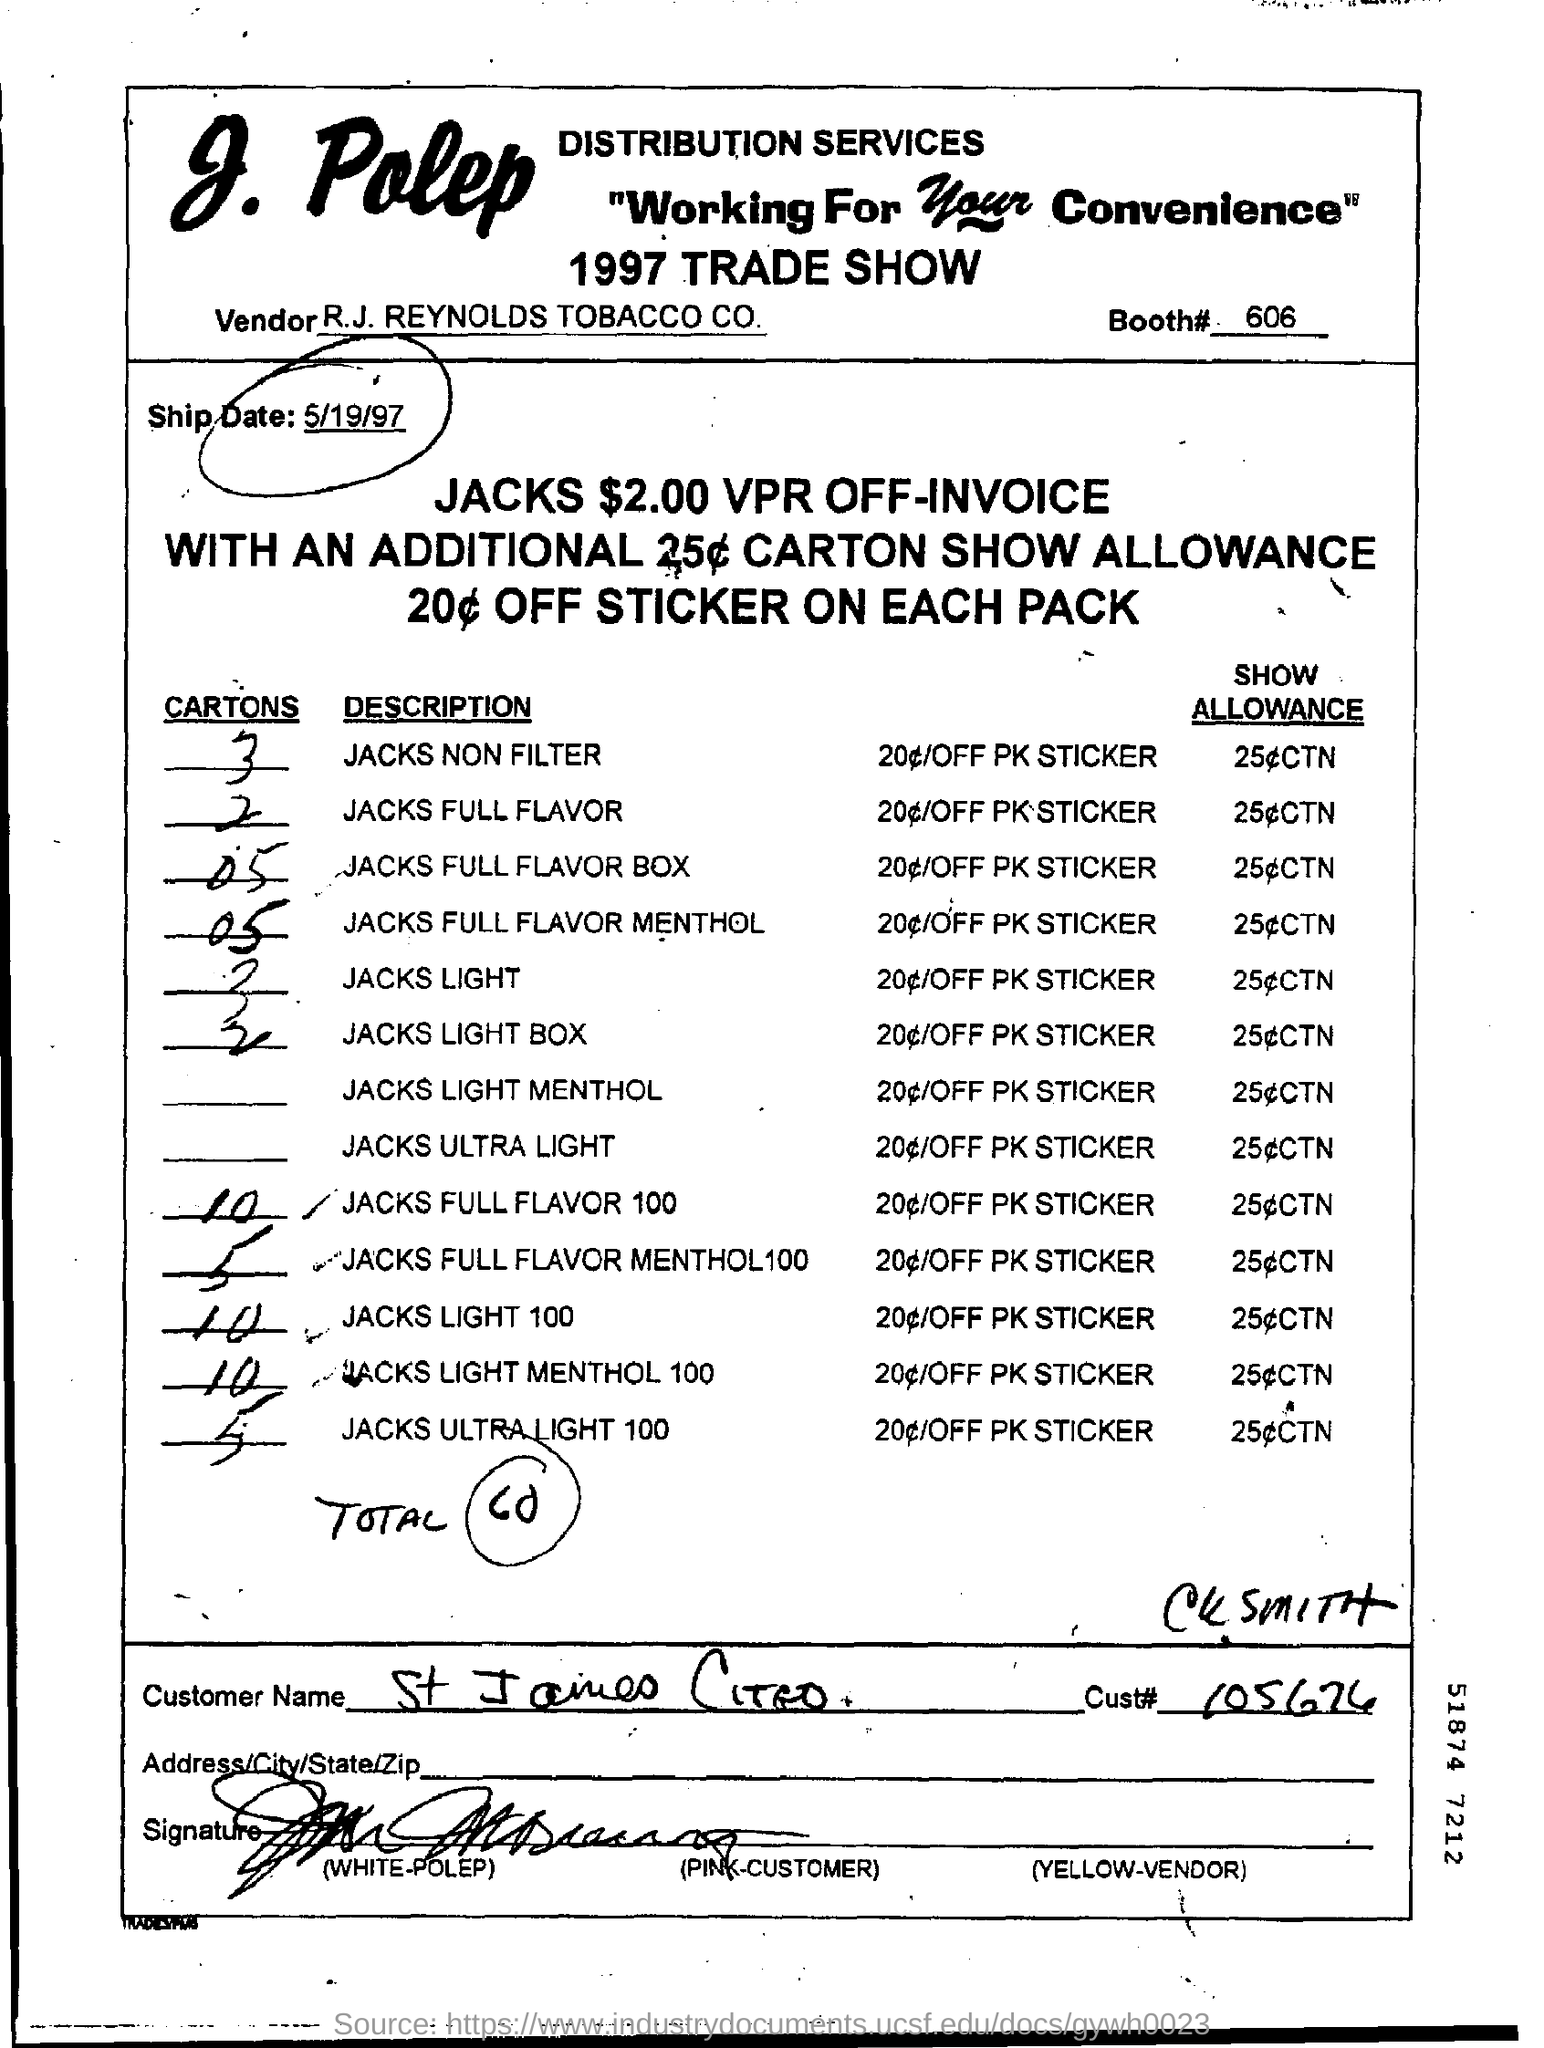Identify some key points in this picture. The total number of cartons in the given document is 60. R.J. Reynolds Tobacco Company is the vendor. The customer ID is 105674... The ship date is 5/19/97. The customer's name is St. James CITEO. 